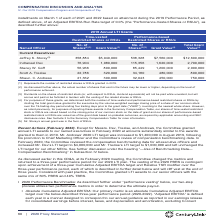According to Centurylink's financial document, What form was Jeffrey K. Storey's annual grant? According to the financial document, in the form of RSUs. The relevant text states: "(5) Mr. Storey’s annual grant was in the form of RSUs...." Also, How was the number of time-vested and performance-based restricted shares or RSUs determined? by dividing the total grant value granted to the executive by the volume-weighted average closing price of a share of our common stock over the 15-trading-day period ending five trading days prior to the grant date (“VWAP”), rounding to the nearest whole share. The document states: "d and performance-based restricted shares or RSUs by dividing the total grant value granted to the executive by the volume-weighted average closing pr..." Also, Which current executives had their LTI targets increased? The document contains multiple relevant values: Indraneel Dev, Shaun. C. Andrews, Scott A. Trezise. From the document: "Indraneel Dev 76,904 1,080,000 115,356 1,620,000 2,700,000 Scott A. Trezise 22,786 320,000 34,180 480,000 800,000 Shaun. C. Andrews 21,362 300,000 32,..." Also, How many current executives have a total grant value above $2,000,000? Counting the relevant items in the document: Jeffrey K. Storey, Indraneel Dev, I find 2 instances. The key data points involved are: Indraneel Dev, Jeffrey K. Storey. Also, can you calculate: What is the difference between Indraneel Dev and Stacey W. Goff's total grant values? Based on the calculation: $2,700,000-$2,000,000, the result is 700000. This is based on the information: "Indraneel Dev 76,904 1,080,000 115,356 1,620,000 2,700,000 Stacey W. Goff 56,966 800,000 85,449 1,200,000 2,000,000..." The key data points involved are: 2,000,000, 2,700,000. Also, can you calculate: What is the average total grant value for current executives? To answer this question, I need to perform calculations using the financial data. The calculation is: ($12,600,000+$2,700,000+$2,000,000+$800,000+$750,000)/5, which equals 3770000. This is based on the information: "Storey (5) 358,884 $5,040,000 538,328 $7,560,000 $12,600,000 Stacey W. Goff 56,966 800,000 85,449 1,200,000 2,000,000 Indraneel Dev 76,904 1,080,000 115,356 1,620,000 2,700,000 Stacey W. Goff 56,966 8..." The key data points involved are: 12,600,000, 2,000,000, 2,700,000. 